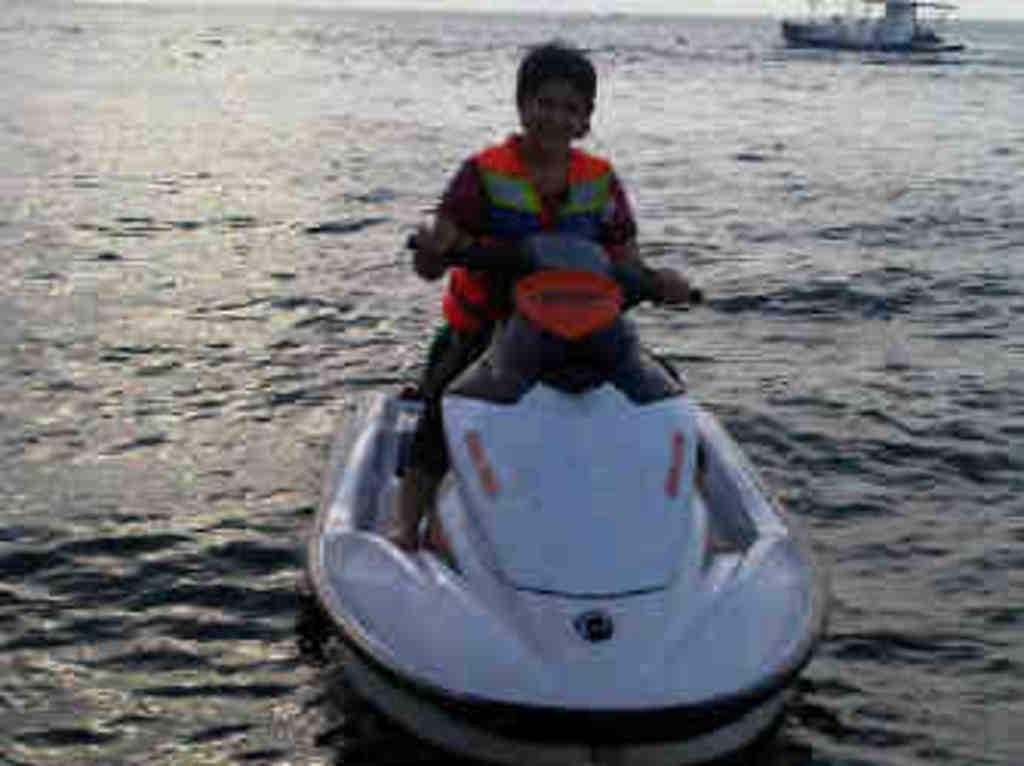What is the person in the image doing? There is a person sitting on a boat in the image. Where is the boat located? The boat is on a river. What other watercraft can be seen in the image? There is a ship in the background of the image. Where is the ship located? The ship is also on the river. What type of box does the achiever use to store their awards in the image? There is no achiever or box present in the image; it features a person sitting on a boat and a ship in the background. 